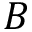Convert formula to latex. <formula><loc_0><loc_0><loc_500><loc_500>B</formula> 